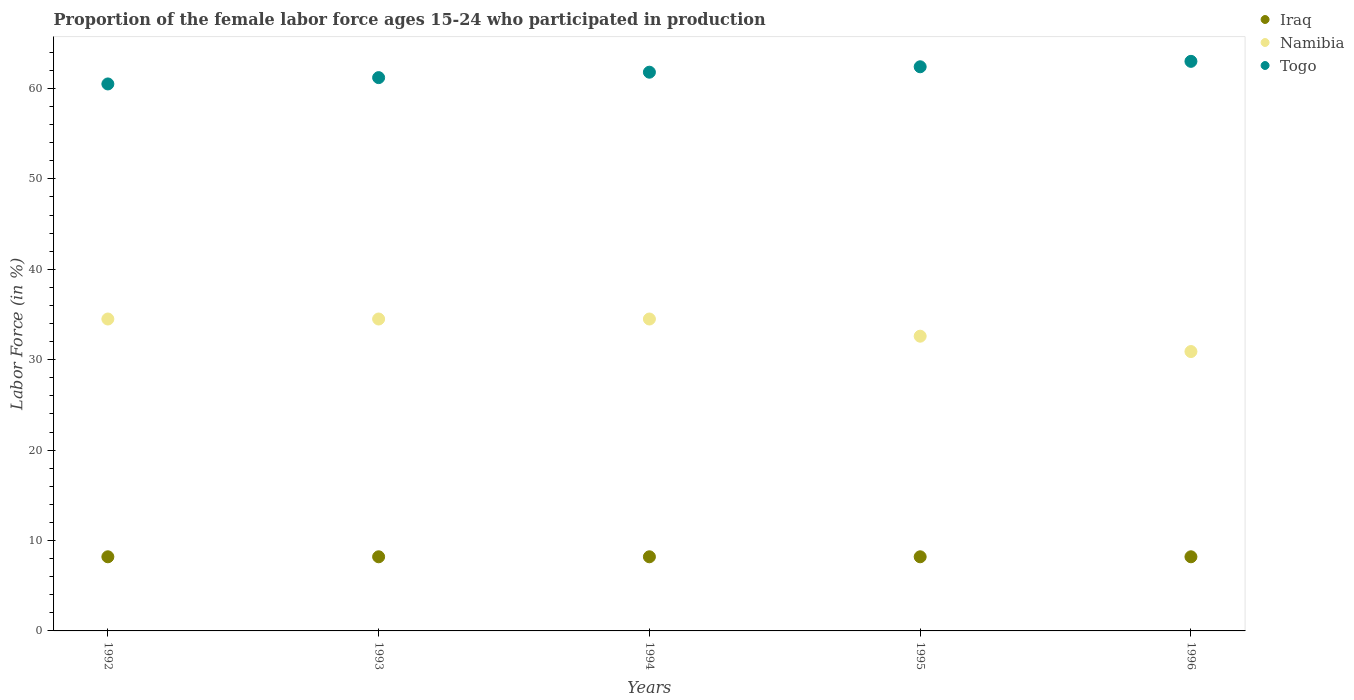How many different coloured dotlines are there?
Your answer should be compact. 3. What is the proportion of the female labor force who participated in production in Iraq in 1992?
Provide a short and direct response. 8.2. Across all years, what is the maximum proportion of the female labor force who participated in production in Iraq?
Your answer should be compact. 8.2. Across all years, what is the minimum proportion of the female labor force who participated in production in Namibia?
Your answer should be compact. 30.9. In which year was the proportion of the female labor force who participated in production in Namibia maximum?
Your answer should be compact. 1992. What is the total proportion of the female labor force who participated in production in Namibia in the graph?
Provide a succinct answer. 167. What is the difference between the proportion of the female labor force who participated in production in Togo in 1993 and that in 1994?
Offer a very short reply. -0.6. What is the difference between the proportion of the female labor force who participated in production in Namibia in 1992 and the proportion of the female labor force who participated in production in Togo in 1996?
Make the answer very short. -28.5. What is the average proportion of the female labor force who participated in production in Togo per year?
Make the answer very short. 61.78. In the year 1995, what is the difference between the proportion of the female labor force who participated in production in Iraq and proportion of the female labor force who participated in production in Togo?
Offer a terse response. -54.2. In how many years, is the proportion of the female labor force who participated in production in Togo greater than 40 %?
Provide a short and direct response. 5. What is the ratio of the proportion of the female labor force who participated in production in Togo in 1992 to that in 1993?
Offer a terse response. 0.99. Is the proportion of the female labor force who participated in production in Iraq in 1994 less than that in 1996?
Ensure brevity in your answer.  No. What is the difference between the highest and the second highest proportion of the female labor force who participated in production in Iraq?
Provide a succinct answer. 0. What is the difference between the highest and the lowest proportion of the female labor force who participated in production in Togo?
Provide a short and direct response. 2.5. In how many years, is the proportion of the female labor force who participated in production in Iraq greater than the average proportion of the female labor force who participated in production in Iraq taken over all years?
Provide a succinct answer. 0. Is the sum of the proportion of the female labor force who participated in production in Namibia in 1992 and 1994 greater than the maximum proportion of the female labor force who participated in production in Togo across all years?
Make the answer very short. Yes. Does the proportion of the female labor force who participated in production in Namibia monotonically increase over the years?
Offer a very short reply. No. How many years are there in the graph?
Offer a terse response. 5. Are the values on the major ticks of Y-axis written in scientific E-notation?
Make the answer very short. No. Does the graph contain any zero values?
Provide a short and direct response. No. Does the graph contain grids?
Provide a succinct answer. No. Where does the legend appear in the graph?
Offer a terse response. Top right. What is the title of the graph?
Provide a succinct answer. Proportion of the female labor force ages 15-24 who participated in production. Does "Fragile and conflict affected situations" appear as one of the legend labels in the graph?
Make the answer very short. No. What is the Labor Force (in %) of Iraq in 1992?
Keep it short and to the point. 8.2. What is the Labor Force (in %) in Namibia in 1992?
Your response must be concise. 34.5. What is the Labor Force (in %) of Togo in 1992?
Provide a succinct answer. 60.5. What is the Labor Force (in %) in Iraq in 1993?
Keep it short and to the point. 8.2. What is the Labor Force (in %) of Namibia in 1993?
Provide a succinct answer. 34.5. What is the Labor Force (in %) in Togo in 1993?
Provide a short and direct response. 61.2. What is the Labor Force (in %) of Iraq in 1994?
Provide a succinct answer. 8.2. What is the Labor Force (in %) of Namibia in 1994?
Provide a short and direct response. 34.5. What is the Labor Force (in %) in Togo in 1994?
Give a very brief answer. 61.8. What is the Labor Force (in %) in Iraq in 1995?
Provide a succinct answer. 8.2. What is the Labor Force (in %) of Namibia in 1995?
Provide a short and direct response. 32.6. What is the Labor Force (in %) of Togo in 1995?
Ensure brevity in your answer.  62.4. What is the Labor Force (in %) of Iraq in 1996?
Your answer should be compact. 8.2. What is the Labor Force (in %) of Namibia in 1996?
Provide a succinct answer. 30.9. What is the Labor Force (in %) of Togo in 1996?
Your answer should be compact. 63. Across all years, what is the maximum Labor Force (in %) of Iraq?
Provide a short and direct response. 8.2. Across all years, what is the maximum Labor Force (in %) in Namibia?
Your answer should be compact. 34.5. Across all years, what is the maximum Labor Force (in %) in Togo?
Offer a very short reply. 63. Across all years, what is the minimum Labor Force (in %) in Iraq?
Ensure brevity in your answer.  8.2. Across all years, what is the minimum Labor Force (in %) in Namibia?
Provide a short and direct response. 30.9. Across all years, what is the minimum Labor Force (in %) of Togo?
Your answer should be compact. 60.5. What is the total Labor Force (in %) in Namibia in the graph?
Offer a terse response. 167. What is the total Labor Force (in %) in Togo in the graph?
Your response must be concise. 308.9. What is the difference between the Labor Force (in %) in Iraq in 1992 and that in 1993?
Ensure brevity in your answer.  0. What is the difference between the Labor Force (in %) in Namibia in 1992 and that in 1993?
Ensure brevity in your answer.  0. What is the difference between the Labor Force (in %) in Namibia in 1992 and that in 1994?
Your response must be concise. 0. What is the difference between the Labor Force (in %) in Togo in 1992 and that in 1994?
Provide a succinct answer. -1.3. What is the difference between the Labor Force (in %) in Iraq in 1992 and that in 1996?
Offer a terse response. 0. What is the difference between the Labor Force (in %) of Namibia in 1992 and that in 1996?
Provide a short and direct response. 3.6. What is the difference between the Labor Force (in %) of Togo in 1992 and that in 1996?
Ensure brevity in your answer.  -2.5. What is the difference between the Labor Force (in %) of Iraq in 1993 and that in 1996?
Offer a terse response. 0. What is the difference between the Labor Force (in %) of Togo in 1994 and that in 1995?
Provide a short and direct response. -0.6. What is the difference between the Labor Force (in %) in Iraq in 1994 and that in 1996?
Ensure brevity in your answer.  0. What is the difference between the Labor Force (in %) of Iraq in 1995 and that in 1996?
Provide a succinct answer. 0. What is the difference between the Labor Force (in %) in Iraq in 1992 and the Labor Force (in %) in Namibia in 1993?
Your response must be concise. -26.3. What is the difference between the Labor Force (in %) in Iraq in 1992 and the Labor Force (in %) in Togo in 1993?
Ensure brevity in your answer.  -53. What is the difference between the Labor Force (in %) in Namibia in 1992 and the Labor Force (in %) in Togo in 1993?
Give a very brief answer. -26.7. What is the difference between the Labor Force (in %) in Iraq in 1992 and the Labor Force (in %) in Namibia in 1994?
Make the answer very short. -26.3. What is the difference between the Labor Force (in %) in Iraq in 1992 and the Labor Force (in %) in Togo in 1994?
Offer a terse response. -53.6. What is the difference between the Labor Force (in %) in Namibia in 1992 and the Labor Force (in %) in Togo in 1994?
Make the answer very short. -27.3. What is the difference between the Labor Force (in %) in Iraq in 1992 and the Labor Force (in %) in Namibia in 1995?
Ensure brevity in your answer.  -24.4. What is the difference between the Labor Force (in %) in Iraq in 1992 and the Labor Force (in %) in Togo in 1995?
Your response must be concise. -54.2. What is the difference between the Labor Force (in %) of Namibia in 1992 and the Labor Force (in %) of Togo in 1995?
Make the answer very short. -27.9. What is the difference between the Labor Force (in %) in Iraq in 1992 and the Labor Force (in %) in Namibia in 1996?
Provide a short and direct response. -22.7. What is the difference between the Labor Force (in %) in Iraq in 1992 and the Labor Force (in %) in Togo in 1996?
Ensure brevity in your answer.  -54.8. What is the difference between the Labor Force (in %) in Namibia in 1992 and the Labor Force (in %) in Togo in 1996?
Your answer should be compact. -28.5. What is the difference between the Labor Force (in %) in Iraq in 1993 and the Labor Force (in %) in Namibia in 1994?
Your response must be concise. -26.3. What is the difference between the Labor Force (in %) of Iraq in 1993 and the Labor Force (in %) of Togo in 1994?
Your response must be concise. -53.6. What is the difference between the Labor Force (in %) in Namibia in 1993 and the Labor Force (in %) in Togo in 1994?
Your answer should be very brief. -27.3. What is the difference between the Labor Force (in %) in Iraq in 1993 and the Labor Force (in %) in Namibia in 1995?
Give a very brief answer. -24.4. What is the difference between the Labor Force (in %) in Iraq in 1993 and the Labor Force (in %) in Togo in 1995?
Offer a very short reply. -54.2. What is the difference between the Labor Force (in %) in Namibia in 1993 and the Labor Force (in %) in Togo in 1995?
Keep it short and to the point. -27.9. What is the difference between the Labor Force (in %) in Iraq in 1993 and the Labor Force (in %) in Namibia in 1996?
Your answer should be very brief. -22.7. What is the difference between the Labor Force (in %) in Iraq in 1993 and the Labor Force (in %) in Togo in 1996?
Your response must be concise. -54.8. What is the difference between the Labor Force (in %) in Namibia in 1993 and the Labor Force (in %) in Togo in 1996?
Your answer should be very brief. -28.5. What is the difference between the Labor Force (in %) of Iraq in 1994 and the Labor Force (in %) of Namibia in 1995?
Provide a short and direct response. -24.4. What is the difference between the Labor Force (in %) in Iraq in 1994 and the Labor Force (in %) in Togo in 1995?
Make the answer very short. -54.2. What is the difference between the Labor Force (in %) of Namibia in 1994 and the Labor Force (in %) of Togo in 1995?
Your response must be concise. -27.9. What is the difference between the Labor Force (in %) in Iraq in 1994 and the Labor Force (in %) in Namibia in 1996?
Your response must be concise. -22.7. What is the difference between the Labor Force (in %) of Iraq in 1994 and the Labor Force (in %) of Togo in 1996?
Provide a succinct answer. -54.8. What is the difference between the Labor Force (in %) in Namibia in 1994 and the Labor Force (in %) in Togo in 1996?
Ensure brevity in your answer.  -28.5. What is the difference between the Labor Force (in %) in Iraq in 1995 and the Labor Force (in %) in Namibia in 1996?
Offer a terse response. -22.7. What is the difference between the Labor Force (in %) in Iraq in 1995 and the Labor Force (in %) in Togo in 1996?
Offer a terse response. -54.8. What is the difference between the Labor Force (in %) of Namibia in 1995 and the Labor Force (in %) of Togo in 1996?
Ensure brevity in your answer.  -30.4. What is the average Labor Force (in %) in Iraq per year?
Your answer should be very brief. 8.2. What is the average Labor Force (in %) of Namibia per year?
Your answer should be very brief. 33.4. What is the average Labor Force (in %) in Togo per year?
Give a very brief answer. 61.78. In the year 1992, what is the difference between the Labor Force (in %) of Iraq and Labor Force (in %) of Namibia?
Your response must be concise. -26.3. In the year 1992, what is the difference between the Labor Force (in %) of Iraq and Labor Force (in %) of Togo?
Your answer should be compact. -52.3. In the year 1993, what is the difference between the Labor Force (in %) in Iraq and Labor Force (in %) in Namibia?
Make the answer very short. -26.3. In the year 1993, what is the difference between the Labor Force (in %) in Iraq and Labor Force (in %) in Togo?
Provide a short and direct response. -53. In the year 1993, what is the difference between the Labor Force (in %) of Namibia and Labor Force (in %) of Togo?
Your answer should be compact. -26.7. In the year 1994, what is the difference between the Labor Force (in %) of Iraq and Labor Force (in %) of Namibia?
Your response must be concise. -26.3. In the year 1994, what is the difference between the Labor Force (in %) in Iraq and Labor Force (in %) in Togo?
Offer a terse response. -53.6. In the year 1994, what is the difference between the Labor Force (in %) in Namibia and Labor Force (in %) in Togo?
Your answer should be very brief. -27.3. In the year 1995, what is the difference between the Labor Force (in %) in Iraq and Labor Force (in %) in Namibia?
Ensure brevity in your answer.  -24.4. In the year 1995, what is the difference between the Labor Force (in %) in Iraq and Labor Force (in %) in Togo?
Provide a short and direct response. -54.2. In the year 1995, what is the difference between the Labor Force (in %) of Namibia and Labor Force (in %) of Togo?
Give a very brief answer. -29.8. In the year 1996, what is the difference between the Labor Force (in %) of Iraq and Labor Force (in %) of Namibia?
Provide a short and direct response. -22.7. In the year 1996, what is the difference between the Labor Force (in %) in Iraq and Labor Force (in %) in Togo?
Provide a short and direct response. -54.8. In the year 1996, what is the difference between the Labor Force (in %) in Namibia and Labor Force (in %) in Togo?
Make the answer very short. -32.1. What is the ratio of the Labor Force (in %) of Iraq in 1992 to that in 1993?
Give a very brief answer. 1. What is the ratio of the Labor Force (in %) of Namibia in 1992 to that in 1993?
Offer a terse response. 1. What is the ratio of the Labor Force (in %) in Namibia in 1992 to that in 1995?
Ensure brevity in your answer.  1.06. What is the ratio of the Labor Force (in %) in Togo in 1992 to that in 1995?
Keep it short and to the point. 0.97. What is the ratio of the Labor Force (in %) of Iraq in 1992 to that in 1996?
Offer a terse response. 1. What is the ratio of the Labor Force (in %) of Namibia in 1992 to that in 1996?
Offer a terse response. 1.12. What is the ratio of the Labor Force (in %) in Togo in 1992 to that in 1996?
Offer a very short reply. 0.96. What is the ratio of the Labor Force (in %) in Togo in 1993 to that in 1994?
Your answer should be very brief. 0.99. What is the ratio of the Labor Force (in %) in Iraq in 1993 to that in 1995?
Provide a short and direct response. 1. What is the ratio of the Labor Force (in %) in Namibia in 1993 to that in 1995?
Ensure brevity in your answer.  1.06. What is the ratio of the Labor Force (in %) of Togo in 1993 to that in 1995?
Give a very brief answer. 0.98. What is the ratio of the Labor Force (in %) in Iraq in 1993 to that in 1996?
Make the answer very short. 1. What is the ratio of the Labor Force (in %) in Namibia in 1993 to that in 1996?
Provide a short and direct response. 1.12. What is the ratio of the Labor Force (in %) of Togo in 1993 to that in 1996?
Make the answer very short. 0.97. What is the ratio of the Labor Force (in %) of Iraq in 1994 to that in 1995?
Give a very brief answer. 1. What is the ratio of the Labor Force (in %) in Namibia in 1994 to that in 1995?
Offer a terse response. 1.06. What is the ratio of the Labor Force (in %) in Togo in 1994 to that in 1995?
Your answer should be compact. 0.99. What is the ratio of the Labor Force (in %) of Namibia in 1994 to that in 1996?
Your answer should be compact. 1.12. What is the ratio of the Labor Force (in %) in Togo in 1994 to that in 1996?
Keep it short and to the point. 0.98. What is the ratio of the Labor Force (in %) in Namibia in 1995 to that in 1996?
Your answer should be very brief. 1.05. What is the ratio of the Labor Force (in %) in Togo in 1995 to that in 1996?
Provide a succinct answer. 0.99. What is the difference between the highest and the second highest Labor Force (in %) in Iraq?
Your response must be concise. 0. What is the difference between the highest and the lowest Labor Force (in %) in Iraq?
Your response must be concise. 0. 